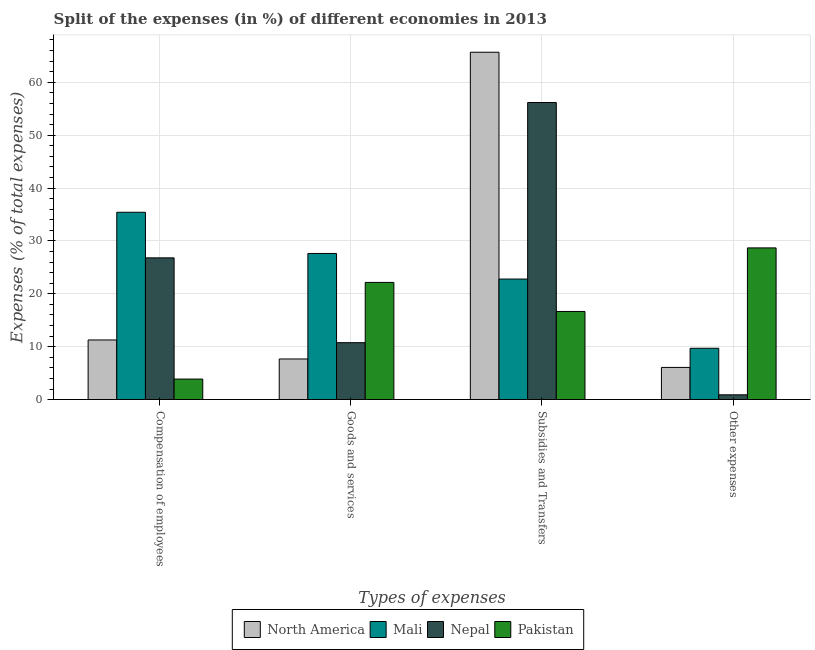How many different coloured bars are there?
Offer a very short reply. 4. How many groups of bars are there?
Your answer should be compact. 4. Are the number of bars per tick equal to the number of legend labels?
Offer a very short reply. Yes. What is the label of the 3rd group of bars from the left?
Make the answer very short. Subsidies and Transfers. What is the percentage of amount spent on other expenses in North America?
Your response must be concise. 6.09. Across all countries, what is the maximum percentage of amount spent on other expenses?
Offer a terse response. 28.68. Across all countries, what is the minimum percentage of amount spent on compensation of employees?
Ensure brevity in your answer.  3.88. In which country was the percentage of amount spent on compensation of employees maximum?
Offer a very short reply. Mali. In which country was the percentage of amount spent on other expenses minimum?
Offer a very short reply. Nepal. What is the total percentage of amount spent on goods and services in the graph?
Make the answer very short. 68.23. What is the difference between the percentage of amount spent on goods and services in Nepal and that in Pakistan?
Make the answer very short. -11.39. What is the difference between the percentage of amount spent on subsidies in Mali and the percentage of amount spent on goods and services in North America?
Give a very brief answer. 15.11. What is the average percentage of amount spent on other expenses per country?
Offer a very short reply. 11.35. What is the difference between the percentage of amount spent on subsidies and percentage of amount spent on goods and services in Nepal?
Ensure brevity in your answer.  45.41. In how many countries, is the percentage of amount spent on subsidies greater than 2 %?
Provide a succinct answer. 4. What is the ratio of the percentage of amount spent on other expenses in Mali to that in Nepal?
Your answer should be compact. 10.73. Is the percentage of amount spent on goods and services in Nepal less than that in North America?
Your answer should be very brief. No. What is the difference between the highest and the second highest percentage of amount spent on subsidies?
Your answer should be very brief. 9.5. What is the difference between the highest and the lowest percentage of amount spent on other expenses?
Offer a very short reply. 27.78. In how many countries, is the percentage of amount spent on subsidies greater than the average percentage of amount spent on subsidies taken over all countries?
Provide a short and direct response. 2. Is the sum of the percentage of amount spent on goods and services in North America and Pakistan greater than the maximum percentage of amount spent on other expenses across all countries?
Ensure brevity in your answer.  Yes. What does the 2nd bar from the right in Goods and services represents?
Offer a terse response. Nepal. Is it the case that in every country, the sum of the percentage of amount spent on compensation of employees and percentage of amount spent on goods and services is greater than the percentage of amount spent on subsidies?
Your answer should be very brief. No. Are all the bars in the graph horizontal?
Give a very brief answer. No. How many countries are there in the graph?
Ensure brevity in your answer.  4. Are the values on the major ticks of Y-axis written in scientific E-notation?
Your answer should be compact. No. Does the graph contain any zero values?
Offer a terse response. No. Does the graph contain grids?
Provide a succinct answer. Yes. How many legend labels are there?
Your answer should be very brief. 4. What is the title of the graph?
Offer a terse response. Split of the expenses (in %) of different economies in 2013. What is the label or title of the X-axis?
Make the answer very short. Types of expenses. What is the label or title of the Y-axis?
Give a very brief answer. Expenses (% of total expenses). What is the Expenses (% of total expenses) of North America in Compensation of employees?
Make the answer very short. 11.28. What is the Expenses (% of total expenses) in Mali in Compensation of employees?
Offer a very short reply. 35.42. What is the Expenses (% of total expenses) of Nepal in Compensation of employees?
Ensure brevity in your answer.  26.8. What is the Expenses (% of total expenses) of Pakistan in Compensation of employees?
Your answer should be very brief. 3.88. What is the Expenses (% of total expenses) of North America in Goods and services?
Make the answer very short. 7.68. What is the Expenses (% of total expenses) in Mali in Goods and services?
Provide a succinct answer. 27.63. What is the Expenses (% of total expenses) in Nepal in Goods and services?
Your answer should be very brief. 10.76. What is the Expenses (% of total expenses) in Pakistan in Goods and services?
Give a very brief answer. 22.16. What is the Expenses (% of total expenses) of North America in Subsidies and Transfers?
Offer a very short reply. 65.68. What is the Expenses (% of total expenses) in Mali in Subsidies and Transfers?
Provide a short and direct response. 22.79. What is the Expenses (% of total expenses) in Nepal in Subsidies and Transfers?
Provide a short and direct response. 56.17. What is the Expenses (% of total expenses) in Pakistan in Subsidies and Transfers?
Offer a terse response. 16.66. What is the Expenses (% of total expenses) of North America in Other expenses?
Ensure brevity in your answer.  6.09. What is the Expenses (% of total expenses) of Mali in Other expenses?
Offer a terse response. 9.71. What is the Expenses (% of total expenses) of Nepal in Other expenses?
Provide a short and direct response. 0.9. What is the Expenses (% of total expenses) of Pakistan in Other expenses?
Keep it short and to the point. 28.68. Across all Types of expenses, what is the maximum Expenses (% of total expenses) of North America?
Make the answer very short. 65.68. Across all Types of expenses, what is the maximum Expenses (% of total expenses) of Mali?
Provide a succinct answer. 35.42. Across all Types of expenses, what is the maximum Expenses (% of total expenses) in Nepal?
Provide a succinct answer. 56.17. Across all Types of expenses, what is the maximum Expenses (% of total expenses) of Pakistan?
Keep it short and to the point. 28.68. Across all Types of expenses, what is the minimum Expenses (% of total expenses) in North America?
Keep it short and to the point. 6.09. Across all Types of expenses, what is the minimum Expenses (% of total expenses) in Mali?
Offer a terse response. 9.71. Across all Types of expenses, what is the minimum Expenses (% of total expenses) in Nepal?
Ensure brevity in your answer.  0.9. Across all Types of expenses, what is the minimum Expenses (% of total expenses) of Pakistan?
Make the answer very short. 3.88. What is the total Expenses (% of total expenses) in North America in the graph?
Keep it short and to the point. 90.72. What is the total Expenses (% of total expenses) in Mali in the graph?
Give a very brief answer. 95.55. What is the total Expenses (% of total expenses) of Nepal in the graph?
Your response must be concise. 94.65. What is the total Expenses (% of total expenses) in Pakistan in the graph?
Your answer should be compact. 71.39. What is the difference between the Expenses (% of total expenses) in North America in Compensation of employees and that in Goods and services?
Offer a terse response. 3.6. What is the difference between the Expenses (% of total expenses) in Mali in Compensation of employees and that in Goods and services?
Your answer should be compact. 7.79. What is the difference between the Expenses (% of total expenses) of Nepal in Compensation of employees and that in Goods and services?
Your answer should be compact. 16.04. What is the difference between the Expenses (% of total expenses) in Pakistan in Compensation of employees and that in Goods and services?
Keep it short and to the point. -18.27. What is the difference between the Expenses (% of total expenses) in North America in Compensation of employees and that in Subsidies and Transfers?
Offer a terse response. -54.4. What is the difference between the Expenses (% of total expenses) of Mali in Compensation of employees and that in Subsidies and Transfers?
Provide a short and direct response. 12.63. What is the difference between the Expenses (% of total expenses) in Nepal in Compensation of employees and that in Subsidies and Transfers?
Keep it short and to the point. -29.37. What is the difference between the Expenses (% of total expenses) in Pakistan in Compensation of employees and that in Subsidies and Transfers?
Ensure brevity in your answer.  -12.78. What is the difference between the Expenses (% of total expenses) in North America in Compensation of employees and that in Other expenses?
Your response must be concise. 5.19. What is the difference between the Expenses (% of total expenses) in Mali in Compensation of employees and that in Other expenses?
Make the answer very short. 25.71. What is the difference between the Expenses (% of total expenses) in Nepal in Compensation of employees and that in Other expenses?
Offer a terse response. 25.9. What is the difference between the Expenses (% of total expenses) of Pakistan in Compensation of employees and that in Other expenses?
Keep it short and to the point. -24.8. What is the difference between the Expenses (% of total expenses) of North America in Goods and services and that in Subsidies and Transfers?
Keep it short and to the point. -58. What is the difference between the Expenses (% of total expenses) in Mali in Goods and services and that in Subsidies and Transfers?
Ensure brevity in your answer.  4.84. What is the difference between the Expenses (% of total expenses) in Nepal in Goods and services and that in Subsidies and Transfers?
Keep it short and to the point. -45.41. What is the difference between the Expenses (% of total expenses) in Pakistan in Goods and services and that in Subsidies and Transfers?
Keep it short and to the point. 5.49. What is the difference between the Expenses (% of total expenses) of North America in Goods and services and that in Other expenses?
Provide a short and direct response. 1.59. What is the difference between the Expenses (% of total expenses) in Mali in Goods and services and that in Other expenses?
Your response must be concise. 17.93. What is the difference between the Expenses (% of total expenses) of Nepal in Goods and services and that in Other expenses?
Ensure brevity in your answer.  9.86. What is the difference between the Expenses (% of total expenses) in Pakistan in Goods and services and that in Other expenses?
Provide a succinct answer. -6.53. What is the difference between the Expenses (% of total expenses) in North America in Subsidies and Transfers and that in Other expenses?
Your response must be concise. 59.59. What is the difference between the Expenses (% of total expenses) in Mali in Subsidies and Transfers and that in Other expenses?
Make the answer very short. 13.09. What is the difference between the Expenses (% of total expenses) of Nepal in Subsidies and Transfers and that in Other expenses?
Your response must be concise. 55.27. What is the difference between the Expenses (% of total expenses) of Pakistan in Subsidies and Transfers and that in Other expenses?
Your response must be concise. -12.02. What is the difference between the Expenses (% of total expenses) of North America in Compensation of employees and the Expenses (% of total expenses) of Mali in Goods and services?
Your answer should be very brief. -16.36. What is the difference between the Expenses (% of total expenses) of North America in Compensation of employees and the Expenses (% of total expenses) of Nepal in Goods and services?
Provide a short and direct response. 0.51. What is the difference between the Expenses (% of total expenses) of North America in Compensation of employees and the Expenses (% of total expenses) of Pakistan in Goods and services?
Offer a very short reply. -10.88. What is the difference between the Expenses (% of total expenses) in Mali in Compensation of employees and the Expenses (% of total expenses) in Nepal in Goods and services?
Provide a succinct answer. 24.66. What is the difference between the Expenses (% of total expenses) in Mali in Compensation of employees and the Expenses (% of total expenses) in Pakistan in Goods and services?
Give a very brief answer. 13.26. What is the difference between the Expenses (% of total expenses) of Nepal in Compensation of employees and the Expenses (% of total expenses) of Pakistan in Goods and services?
Offer a very short reply. 4.65. What is the difference between the Expenses (% of total expenses) of North America in Compensation of employees and the Expenses (% of total expenses) of Mali in Subsidies and Transfers?
Offer a very short reply. -11.51. What is the difference between the Expenses (% of total expenses) in North America in Compensation of employees and the Expenses (% of total expenses) in Nepal in Subsidies and Transfers?
Ensure brevity in your answer.  -44.9. What is the difference between the Expenses (% of total expenses) in North America in Compensation of employees and the Expenses (% of total expenses) in Pakistan in Subsidies and Transfers?
Provide a short and direct response. -5.39. What is the difference between the Expenses (% of total expenses) of Mali in Compensation of employees and the Expenses (% of total expenses) of Nepal in Subsidies and Transfers?
Provide a succinct answer. -20.75. What is the difference between the Expenses (% of total expenses) of Mali in Compensation of employees and the Expenses (% of total expenses) of Pakistan in Subsidies and Transfers?
Your answer should be compact. 18.76. What is the difference between the Expenses (% of total expenses) of Nepal in Compensation of employees and the Expenses (% of total expenses) of Pakistan in Subsidies and Transfers?
Your response must be concise. 10.14. What is the difference between the Expenses (% of total expenses) in North America in Compensation of employees and the Expenses (% of total expenses) in Mali in Other expenses?
Give a very brief answer. 1.57. What is the difference between the Expenses (% of total expenses) in North America in Compensation of employees and the Expenses (% of total expenses) in Nepal in Other expenses?
Provide a succinct answer. 10.37. What is the difference between the Expenses (% of total expenses) in North America in Compensation of employees and the Expenses (% of total expenses) in Pakistan in Other expenses?
Offer a very short reply. -17.41. What is the difference between the Expenses (% of total expenses) in Mali in Compensation of employees and the Expenses (% of total expenses) in Nepal in Other expenses?
Offer a very short reply. 34.52. What is the difference between the Expenses (% of total expenses) of Mali in Compensation of employees and the Expenses (% of total expenses) of Pakistan in Other expenses?
Offer a terse response. 6.74. What is the difference between the Expenses (% of total expenses) in Nepal in Compensation of employees and the Expenses (% of total expenses) in Pakistan in Other expenses?
Provide a succinct answer. -1.88. What is the difference between the Expenses (% of total expenses) of North America in Goods and services and the Expenses (% of total expenses) of Mali in Subsidies and Transfers?
Your response must be concise. -15.11. What is the difference between the Expenses (% of total expenses) of North America in Goods and services and the Expenses (% of total expenses) of Nepal in Subsidies and Transfers?
Provide a short and direct response. -48.49. What is the difference between the Expenses (% of total expenses) of North America in Goods and services and the Expenses (% of total expenses) of Pakistan in Subsidies and Transfers?
Offer a terse response. -8.98. What is the difference between the Expenses (% of total expenses) of Mali in Goods and services and the Expenses (% of total expenses) of Nepal in Subsidies and Transfers?
Offer a terse response. -28.54. What is the difference between the Expenses (% of total expenses) of Mali in Goods and services and the Expenses (% of total expenses) of Pakistan in Subsidies and Transfers?
Offer a very short reply. 10.97. What is the difference between the Expenses (% of total expenses) of Nepal in Goods and services and the Expenses (% of total expenses) of Pakistan in Subsidies and Transfers?
Offer a terse response. -5.9. What is the difference between the Expenses (% of total expenses) of North America in Goods and services and the Expenses (% of total expenses) of Mali in Other expenses?
Your answer should be very brief. -2.02. What is the difference between the Expenses (% of total expenses) in North America in Goods and services and the Expenses (% of total expenses) in Nepal in Other expenses?
Give a very brief answer. 6.78. What is the difference between the Expenses (% of total expenses) of North America in Goods and services and the Expenses (% of total expenses) of Pakistan in Other expenses?
Give a very brief answer. -21. What is the difference between the Expenses (% of total expenses) in Mali in Goods and services and the Expenses (% of total expenses) in Nepal in Other expenses?
Make the answer very short. 26.73. What is the difference between the Expenses (% of total expenses) of Mali in Goods and services and the Expenses (% of total expenses) of Pakistan in Other expenses?
Provide a short and direct response. -1.05. What is the difference between the Expenses (% of total expenses) in Nepal in Goods and services and the Expenses (% of total expenses) in Pakistan in Other expenses?
Give a very brief answer. -17.92. What is the difference between the Expenses (% of total expenses) in North America in Subsidies and Transfers and the Expenses (% of total expenses) in Mali in Other expenses?
Ensure brevity in your answer.  55.97. What is the difference between the Expenses (% of total expenses) of North America in Subsidies and Transfers and the Expenses (% of total expenses) of Nepal in Other expenses?
Provide a short and direct response. 64.77. What is the difference between the Expenses (% of total expenses) in North America in Subsidies and Transfers and the Expenses (% of total expenses) in Pakistan in Other expenses?
Provide a short and direct response. 36.99. What is the difference between the Expenses (% of total expenses) of Mali in Subsidies and Transfers and the Expenses (% of total expenses) of Nepal in Other expenses?
Your response must be concise. 21.89. What is the difference between the Expenses (% of total expenses) of Mali in Subsidies and Transfers and the Expenses (% of total expenses) of Pakistan in Other expenses?
Give a very brief answer. -5.89. What is the difference between the Expenses (% of total expenses) in Nepal in Subsidies and Transfers and the Expenses (% of total expenses) in Pakistan in Other expenses?
Offer a terse response. 27.49. What is the average Expenses (% of total expenses) of North America per Types of expenses?
Provide a succinct answer. 22.68. What is the average Expenses (% of total expenses) of Mali per Types of expenses?
Offer a terse response. 23.89. What is the average Expenses (% of total expenses) in Nepal per Types of expenses?
Provide a short and direct response. 23.66. What is the average Expenses (% of total expenses) of Pakistan per Types of expenses?
Give a very brief answer. 17.85. What is the difference between the Expenses (% of total expenses) in North America and Expenses (% of total expenses) in Mali in Compensation of employees?
Ensure brevity in your answer.  -24.14. What is the difference between the Expenses (% of total expenses) in North America and Expenses (% of total expenses) in Nepal in Compensation of employees?
Give a very brief answer. -15.53. What is the difference between the Expenses (% of total expenses) in North America and Expenses (% of total expenses) in Pakistan in Compensation of employees?
Your answer should be compact. 7.39. What is the difference between the Expenses (% of total expenses) in Mali and Expenses (% of total expenses) in Nepal in Compensation of employees?
Your answer should be compact. 8.62. What is the difference between the Expenses (% of total expenses) in Mali and Expenses (% of total expenses) in Pakistan in Compensation of employees?
Your response must be concise. 31.54. What is the difference between the Expenses (% of total expenses) of Nepal and Expenses (% of total expenses) of Pakistan in Compensation of employees?
Make the answer very short. 22.92. What is the difference between the Expenses (% of total expenses) in North America and Expenses (% of total expenses) in Mali in Goods and services?
Your response must be concise. -19.95. What is the difference between the Expenses (% of total expenses) in North America and Expenses (% of total expenses) in Nepal in Goods and services?
Your answer should be very brief. -3.08. What is the difference between the Expenses (% of total expenses) in North America and Expenses (% of total expenses) in Pakistan in Goods and services?
Offer a terse response. -14.48. What is the difference between the Expenses (% of total expenses) of Mali and Expenses (% of total expenses) of Nepal in Goods and services?
Ensure brevity in your answer.  16.87. What is the difference between the Expenses (% of total expenses) of Mali and Expenses (% of total expenses) of Pakistan in Goods and services?
Ensure brevity in your answer.  5.48. What is the difference between the Expenses (% of total expenses) in Nepal and Expenses (% of total expenses) in Pakistan in Goods and services?
Your response must be concise. -11.39. What is the difference between the Expenses (% of total expenses) in North America and Expenses (% of total expenses) in Mali in Subsidies and Transfers?
Offer a terse response. 42.89. What is the difference between the Expenses (% of total expenses) of North America and Expenses (% of total expenses) of Nepal in Subsidies and Transfers?
Offer a terse response. 9.5. What is the difference between the Expenses (% of total expenses) of North America and Expenses (% of total expenses) of Pakistan in Subsidies and Transfers?
Provide a succinct answer. 49.01. What is the difference between the Expenses (% of total expenses) of Mali and Expenses (% of total expenses) of Nepal in Subsidies and Transfers?
Your response must be concise. -33.38. What is the difference between the Expenses (% of total expenses) of Mali and Expenses (% of total expenses) of Pakistan in Subsidies and Transfers?
Offer a terse response. 6.13. What is the difference between the Expenses (% of total expenses) in Nepal and Expenses (% of total expenses) in Pakistan in Subsidies and Transfers?
Offer a very short reply. 39.51. What is the difference between the Expenses (% of total expenses) of North America and Expenses (% of total expenses) of Mali in Other expenses?
Offer a very short reply. -3.62. What is the difference between the Expenses (% of total expenses) of North America and Expenses (% of total expenses) of Nepal in Other expenses?
Make the answer very short. 5.18. What is the difference between the Expenses (% of total expenses) in North America and Expenses (% of total expenses) in Pakistan in Other expenses?
Provide a short and direct response. -22.6. What is the difference between the Expenses (% of total expenses) of Mali and Expenses (% of total expenses) of Nepal in Other expenses?
Your answer should be very brief. 8.8. What is the difference between the Expenses (% of total expenses) of Mali and Expenses (% of total expenses) of Pakistan in Other expenses?
Your answer should be compact. -18.98. What is the difference between the Expenses (% of total expenses) in Nepal and Expenses (% of total expenses) in Pakistan in Other expenses?
Provide a short and direct response. -27.78. What is the ratio of the Expenses (% of total expenses) of North America in Compensation of employees to that in Goods and services?
Your answer should be very brief. 1.47. What is the ratio of the Expenses (% of total expenses) in Mali in Compensation of employees to that in Goods and services?
Your answer should be compact. 1.28. What is the ratio of the Expenses (% of total expenses) of Nepal in Compensation of employees to that in Goods and services?
Keep it short and to the point. 2.49. What is the ratio of the Expenses (% of total expenses) of Pakistan in Compensation of employees to that in Goods and services?
Keep it short and to the point. 0.18. What is the ratio of the Expenses (% of total expenses) of North America in Compensation of employees to that in Subsidies and Transfers?
Provide a succinct answer. 0.17. What is the ratio of the Expenses (% of total expenses) in Mali in Compensation of employees to that in Subsidies and Transfers?
Give a very brief answer. 1.55. What is the ratio of the Expenses (% of total expenses) of Nepal in Compensation of employees to that in Subsidies and Transfers?
Your answer should be compact. 0.48. What is the ratio of the Expenses (% of total expenses) of Pakistan in Compensation of employees to that in Subsidies and Transfers?
Keep it short and to the point. 0.23. What is the ratio of the Expenses (% of total expenses) in North America in Compensation of employees to that in Other expenses?
Ensure brevity in your answer.  1.85. What is the ratio of the Expenses (% of total expenses) of Mali in Compensation of employees to that in Other expenses?
Offer a terse response. 3.65. What is the ratio of the Expenses (% of total expenses) in Nepal in Compensation of employees to that in Other expenses?
Offer a terse response. 29.63. What is the ratio of the Expenses (% of total expenses) of Pakistan in Compensation of employees to that in Other expenses?
Provide a succinct answer. 0.14. What is the ratio of the Expenses (% of total expenses) of North America in Goods and services to that in Subsidies and Transfers?
Give a very brief answer. 0.12. What is the ratio of the Expenses (% of total expenses) of Mali in Goods and services to that in Subsidies and Transfers?
Make the answer very short. 1.21. What is the ratio of the Expenses (% of total expenses) in Nepal in Goods and services to that in Subsidies and Transfers?
Offer a very short reply. 0.19. What is the ratio of the Expenses (% of total expenses) in Pakistan in Goods and services to that in Subsidies and Transfers?
Offer a very short reply. 1.33. What is the ratio of the Expenses (% of total expenses) in North America in Goods and services to that in Other expenses?
Offer a terse response. 1.26. What is the ratio of the Expenses (% of total expenses) in Mali in Goods and services to that in Other expenses?
Your answer should be compact. 2.85. What is the ratio of the Expenses (% of total expenses) of Nepal in Goods and services to that in Other expenses?
Keep it short and to the point. 11.9. What is the ratio of the Expenses (% of total expenses) in Pakistan in Goods and services to that in Other expenses?
Offer a very short reply. 0.77. What is the ratio of the Expenses (% of total expenses) in North America in Subsidies and Transfers to that in Other expenses?
Provide a succinct answer. 10.79. What is the ratio of the Expenses (% of total expenses) of Mali in Subsidies and Transfers to that in Other expenses?
Your answer should be compact. 2.35. What is the ratio of the Expenses (% of total expenses) in Nepal in Subsidies and Transfers to that in Other expenses?
Provide a succinct answer. 62.09. What is the ratio of the Expenses (% of total expenses) in Pakistan in Subsidies and Transfers to that in Other expenses?
Provide a short and direct response. 0.58. What is the difference between the highest and the second highest Expenses (% of total expenses) of North America?
Offer a very short reply. 54.4. What is the difference between the highest and the second highest Expenses (% of total expenses) of Mali?
Give a very brief answer. 7.79. What is the difference between the highest and the second highest Expenses (% of total expenses) in Nepal?
Ensure brevity in your answer.  29.37. What is the difference between the highest and the second highest Expenses (% of total expenses) in Pakistan?
Provide a succinct answer. 6.53. What is the difference between the highest and the lowest Expenses (% of total expenses) in North America?
Give a very brief answer. 59.59. What is the difference between the highest and the lowest Expenses (% of total expenses) in Mali?
Offer a terse response. 25.71. What is the difference between the highest and the lowest Expenses (% of total expenses) of Nepal?
Offer a very short reply. 55.27. What is the difference between the highest and the lowest Expenses (% of total expenses) in Pakistan?
Offer a terse response. 24.8. 